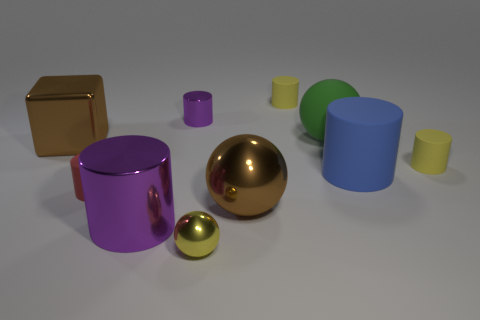Subtract all brown metal balls. How many balls are left? 2 Subtract all yellow spheres. How many spheres are left? 2 Subtract all blocks. How many objects are left? 9 Subtract 2 balls. How many balls are left? 1 Add 7 large red shiny balls. How many large red shiny balls exist? 7 Subtract 0 purple balls. How many objects are left? 10 Subtract all cyan spheres. Subtract all brown cubes. How many spheres are left? 3 Subtract all blue cylinders. How many green balls are left? 1 Subtract all purple cylinders. Subtract all rubber objects. How many objects are left? 3 Add 9 large matte balls. How many large matte balls are left? 10 